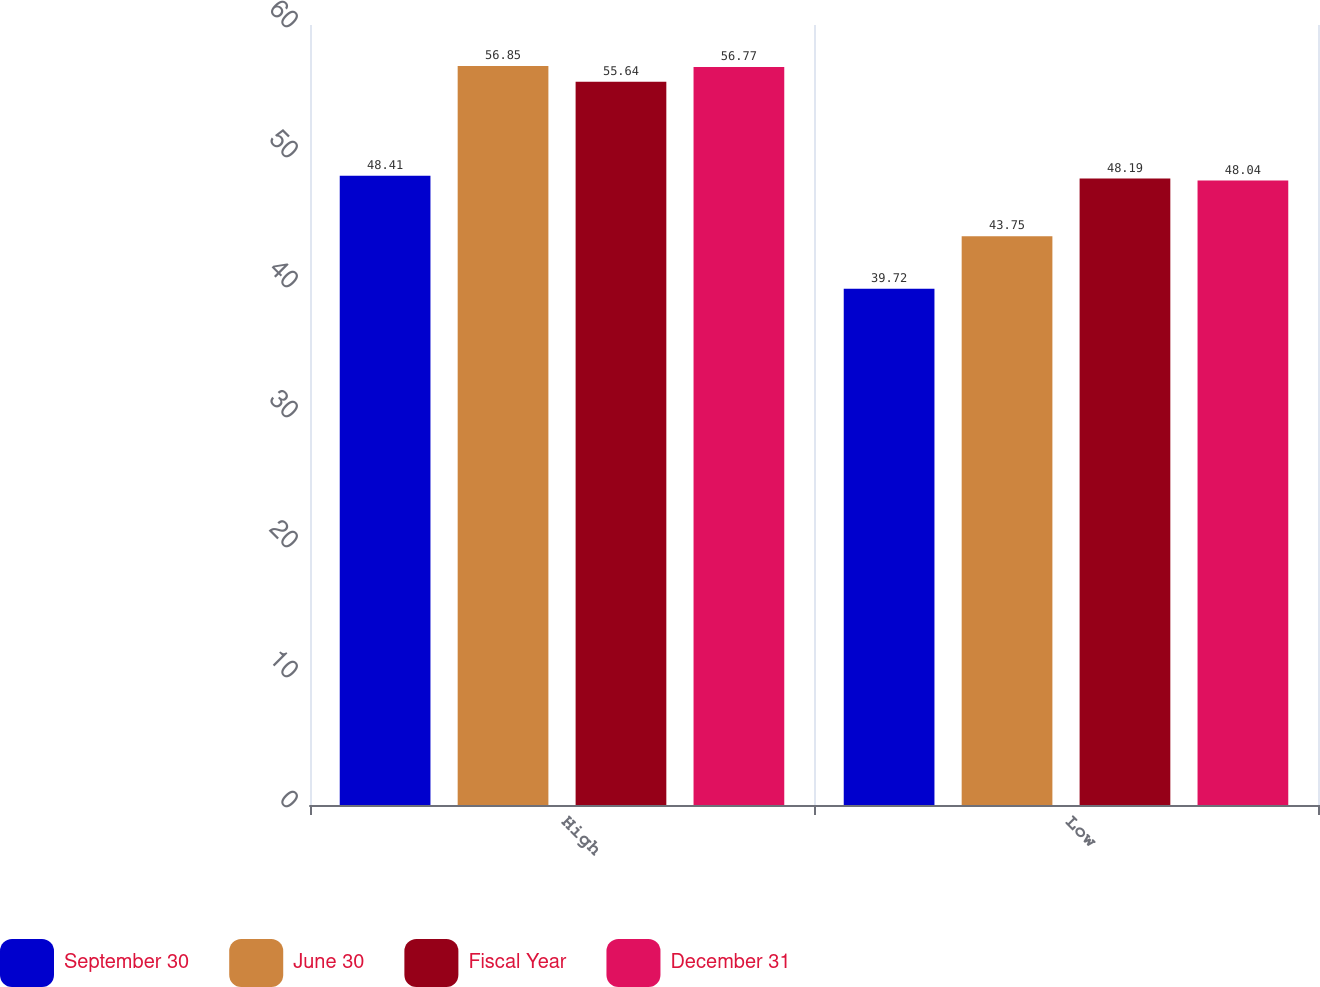<chart> <loc_0><loc_0><loc_500><loc_500><stacked_bar_chart><ecel><fcel>High<fcel>Low<nl><fcel>September 30<fcel>48.41<fcel>39.72<nl><fcel>June 30<fcel>56.85<fcel>43.75<nl><fcel>Fiscal Year<fcel>55.64<fcel>48.19<nl><fcel>December 31<fcel>56.77<fcel>48.04<nl></chart> 